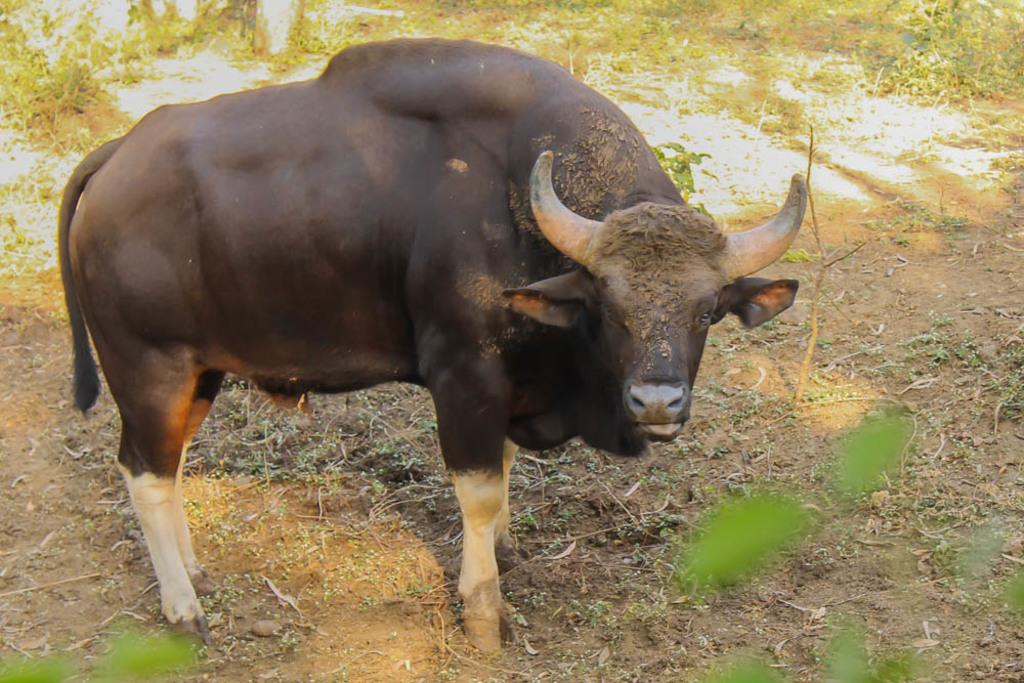What animal is the main subject of the image? There is a bison in the image. Where is the bison located in the image? The bison is standing on a muddy path. What type of vegetation can be seen behind the bison? There is a surface with grass plants visible behind the bison. What type of punishment is the bison receiving in the image? There is no indication of punishment in the image; the bison is simply standing on a muddy path. What is the bison preparing for dinner in the image? There is no indication of the bison preparing for dinner in the image; it is simply standing on a muddy path. 